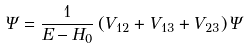<formula> <loc_0><loc_0><loc_500><loc_500>\Psi = \frac { 1 } { E - H _ { 0 } } \left ( V _ { 1 2 } + V _ { 1 3 } + V _ { 2 3 } \right ) \Psi</formula> 